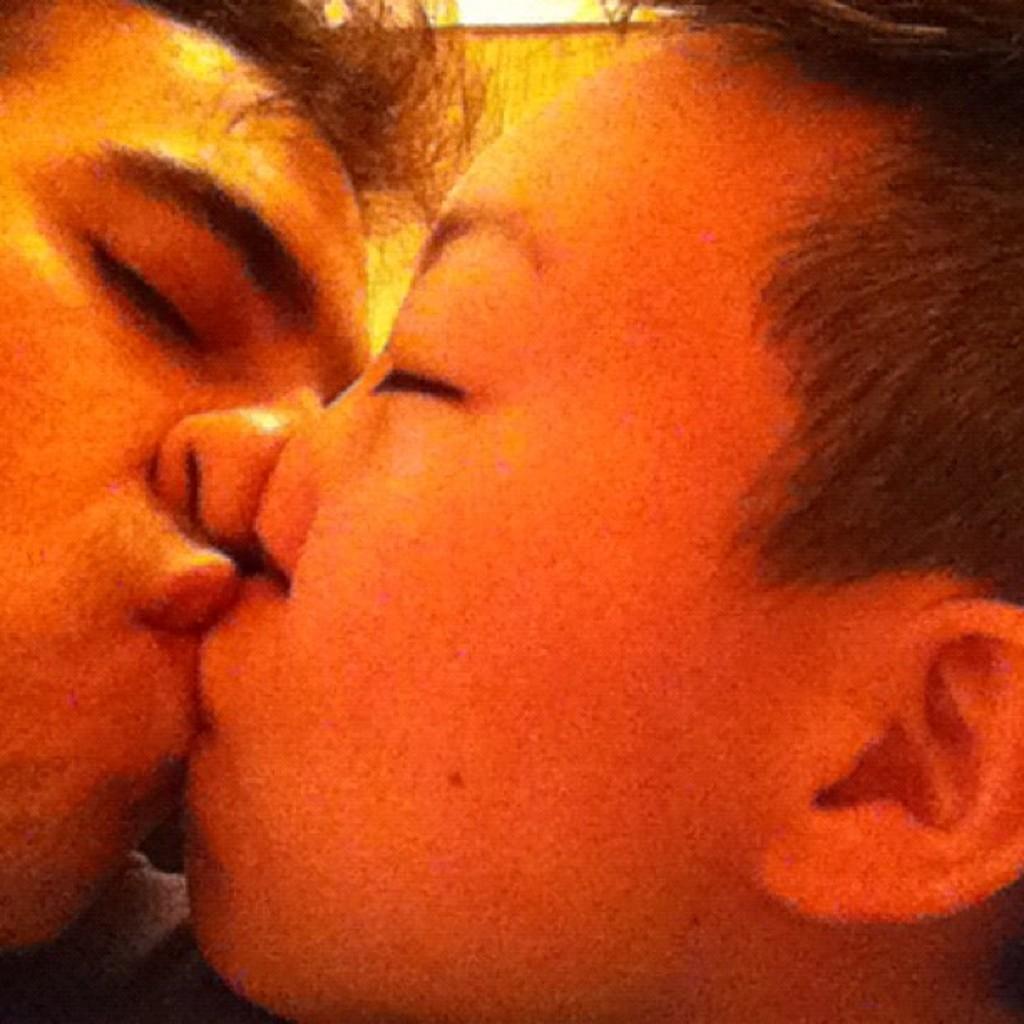Please provide a concise description of this image. In the foreground of this image, there are two people kissing each other. 